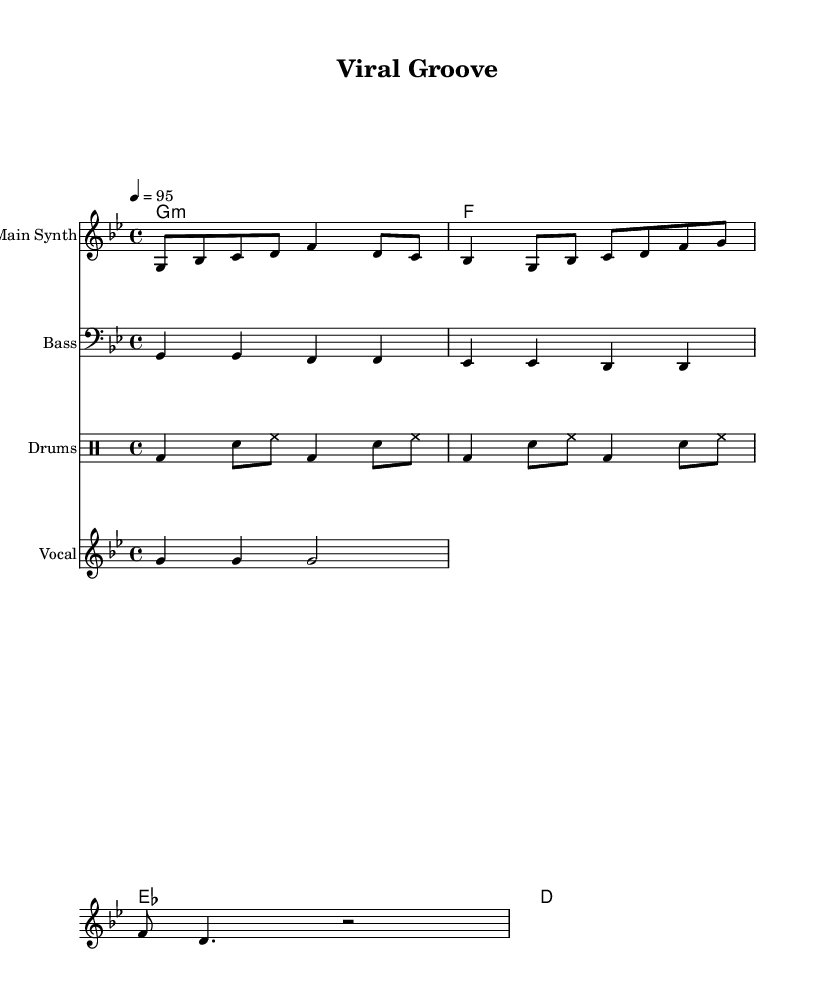What is the key signature of this music? The key signature is G minor, which contains two flats: B flat and E flat. This can be identified at the beginning of the music sheet where the key signature is indicated.
Answer: G minor What is the time signature of this music? The time signature is 4/4, which means there are four beats in a measure and the quarter note receives one beat. This is shown at the beginning of the music where the time signature is displayed.
Answer: 4/4 What is the tempo marking of this music? The tempo marking is 4 equals 95, signifying that there should be 95 beats per minute. This is visible in the tempo indication found at the beginning of the score.
Answer: 95 Which instrument plays the bass line? The bass line is played by the instrument labeled "Bass," and it is indicated on the staff with a bass clef. This can be seen in the score where it specifically mentions “Bass” as the instrument name above the staff.
Answer: Bass How many measures are in the main synth part? The main synth part consists of 4 measures, as evidenced by counting the groupings of notes and rests organized within the staff, each separated by a vertical bar which signifies the end of a measure.
Answer: 4 What lyric is associated with the vocal sample? The lyric associated with the vocal sample is "Get up and move," which is written directly below the vocal sample notes, providing the text that corresponds to the music.
Answer: Get up and move What type of drum pattern is used in this piece? The drum pattern used is a standard hip hop beat, indicated by a combination of bass drum (bd), snare (sn), and hi-hat (hh) that features a consistent rhythmic structure typical to hip hop music. This is visible in the drummode section of the score.
Answer: Hip hop beat 